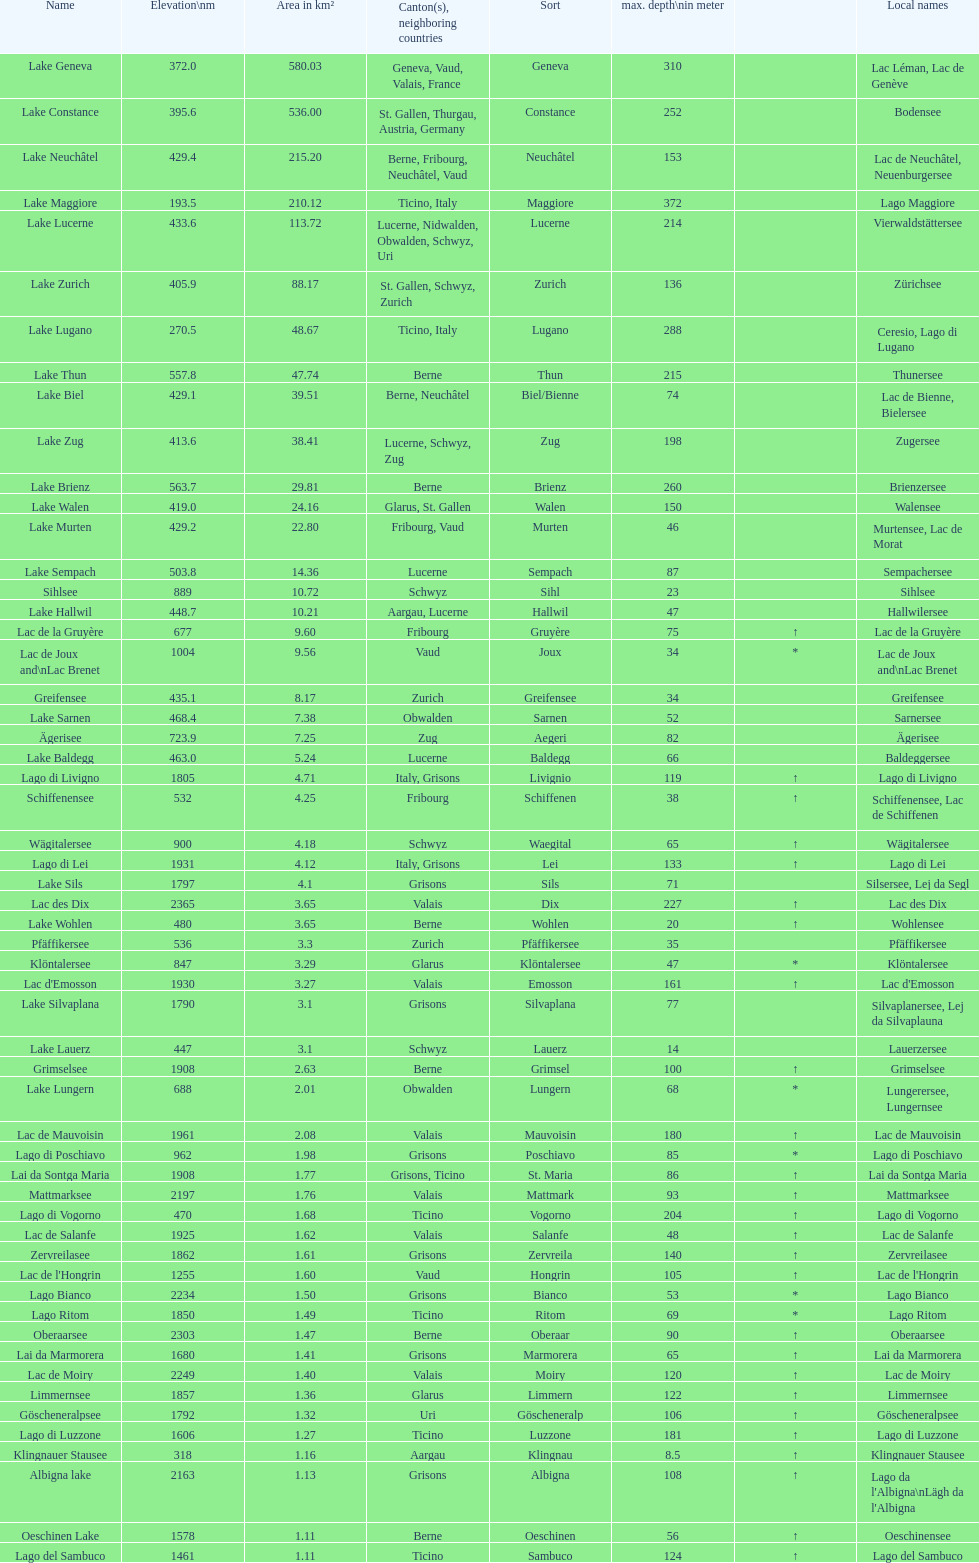Which lake is smaller in area km²? albigna lake or oeschinen lake? Oeschinen Lake. 